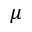Convert formula to latex. <formula><loc_0><loc_0><loc_500><loc_500>\mu</formula> 